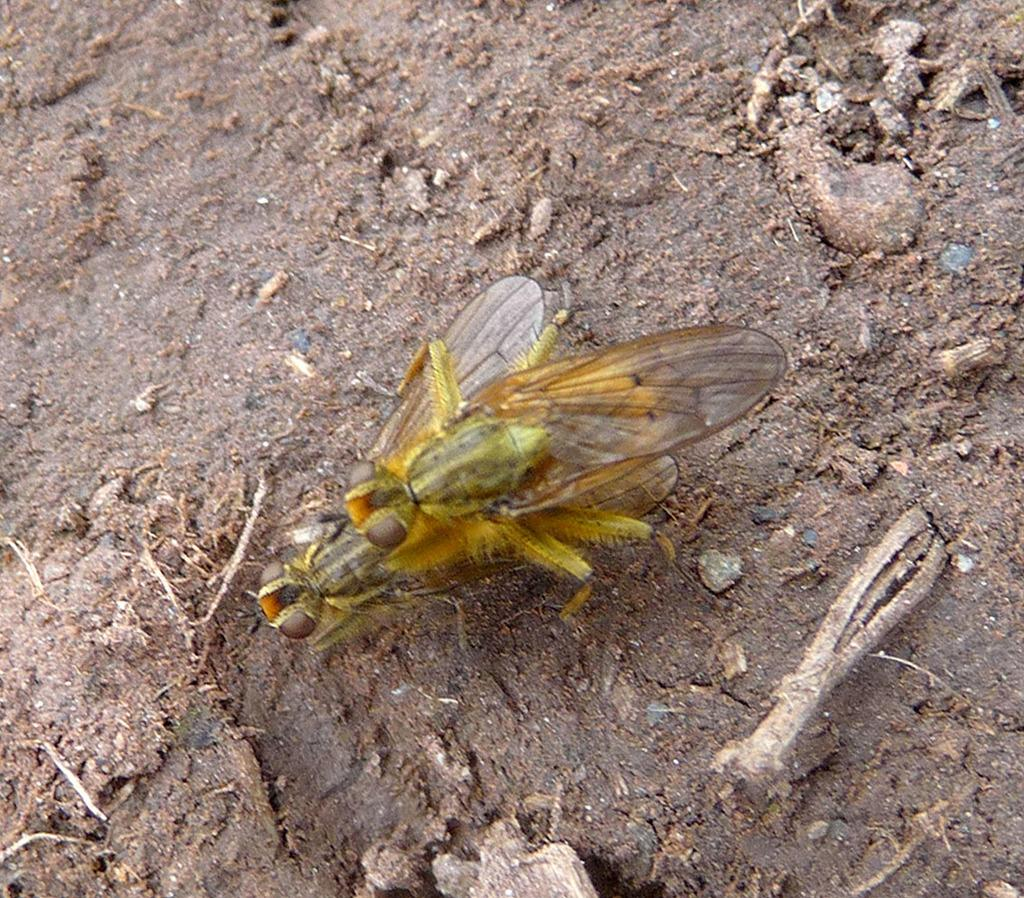What is the main subject in the center of the image? There are aliens in the center of the image. Where are the aliens located in the image? The aliens are on the ground. What other objects can be seen in the image? There are some twigs in the image. What type of suit is the alien wearing in the image? There is no suit visible on the aliens in the image. How does the spark from the alien's suit help them in the image? There is no spark or suit present on the aliens in the image. 